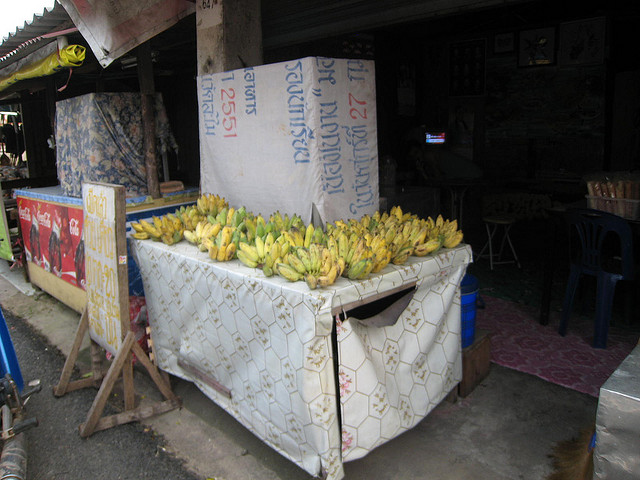Please transcribe the text in this image. 2551 27 